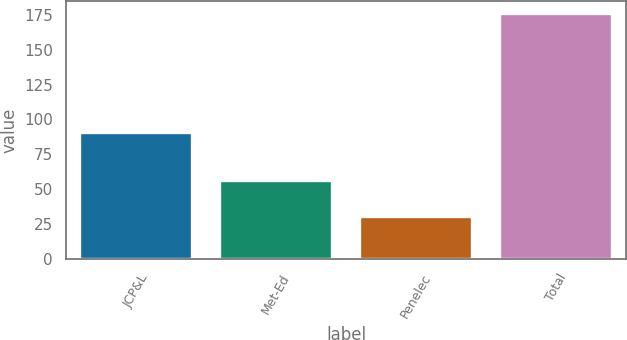Convert chart to OTSL. <chart><loc_0><loc_0><loc_500><loc_500><bar_chart><fcel>JCP&L<fcel>Met-Ed<fcel>Penelec<fcel>Total<nl><fcel>90<fcel>56<fcel>30<fcel>176<nl></chart> 